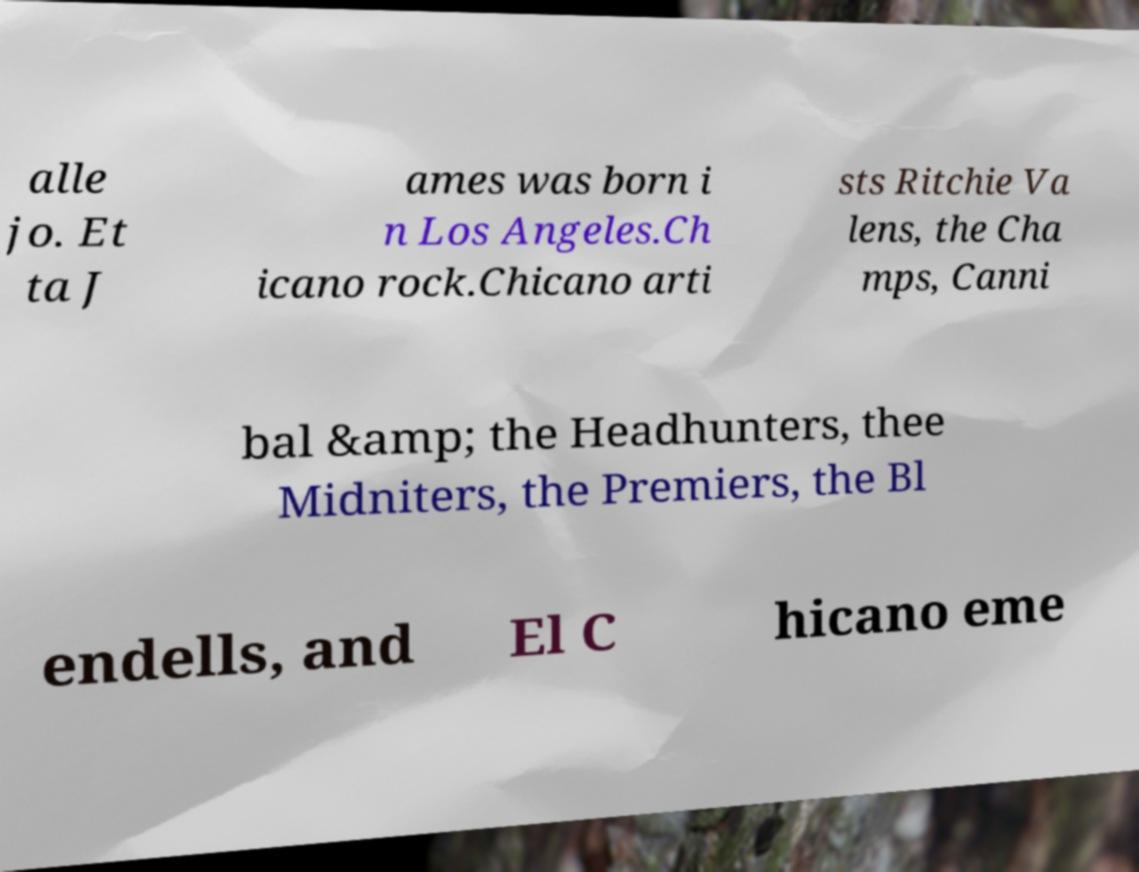There's text embedded in this image that I need extracted. Can you transcribe it verbatim? alle jo. Et ta J ames was born i n Los Angeles.Ch icano rock.Chicano arti sts Ritchie Va lens, the Cha mps, Canni bal &amp; the Headhunters, thee Midniters, the Premiers, the Bl endells, and El C hicano eme 